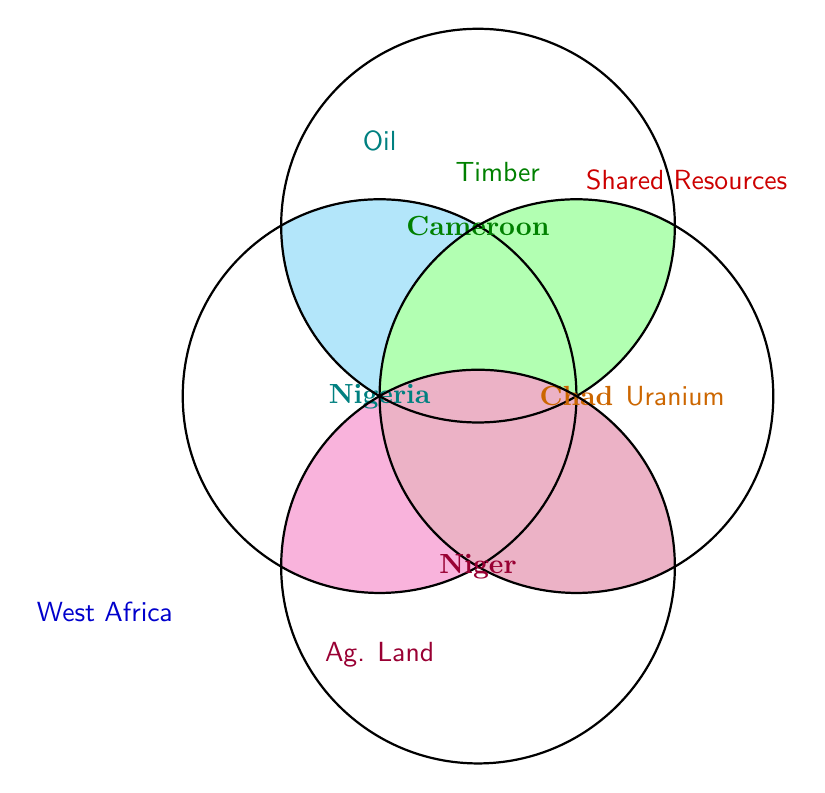What resources are common between Nigeria and Chad? Nigeria and Chad intersect in the Venn Diagram, sharing the resource 'Oil' and 'Agricultural land'.
Answer: Oil, Agricultural land Which countries share the resource Uranium? Chad and Niger both have the resource 'Uranium' as represented in the overlapping area of their respective circles.
Answer: Chad, Niger How many shared resources are there between Nigeria and Niger? Nigeria and Niger share the resources 'Oil' and 'Agricultural land', indicated by the overlapping sections of their respective circles.
Answer: 2 What is the unique resource for Cameroon? The diagram shows Timber inside only the circle for Cameroon and not in any overlaps, indicating it is unique to Cameroon.
Answer: Timber Do Nigeria and Cameroon share any resources with each other? Nigeria and Cameroon share 'Oil' and 'Agricultural land', as represented by the overlapping sections of their circles in the Venn Diagram.
Answer: Yes How many resources does Chad share with any other country? Chad shares 'Oil' and 'Agricultural land' with Nigeria, and 'Uranium' with Niger, totaling three shared resources.
Answer: 3 Is Limestone shared among any countries? Limestone is exclusively within the Benin circle and does not overlap with any other circles, indicating it is not shared with any other country.
Answer: No What resource is common among Nigeria, Cameroon, and Chad? The shared area of the circles representing Nigeria, Cameroon, and Chad indicates 'Oil' as a common resource among all three.
Answer: Oil 